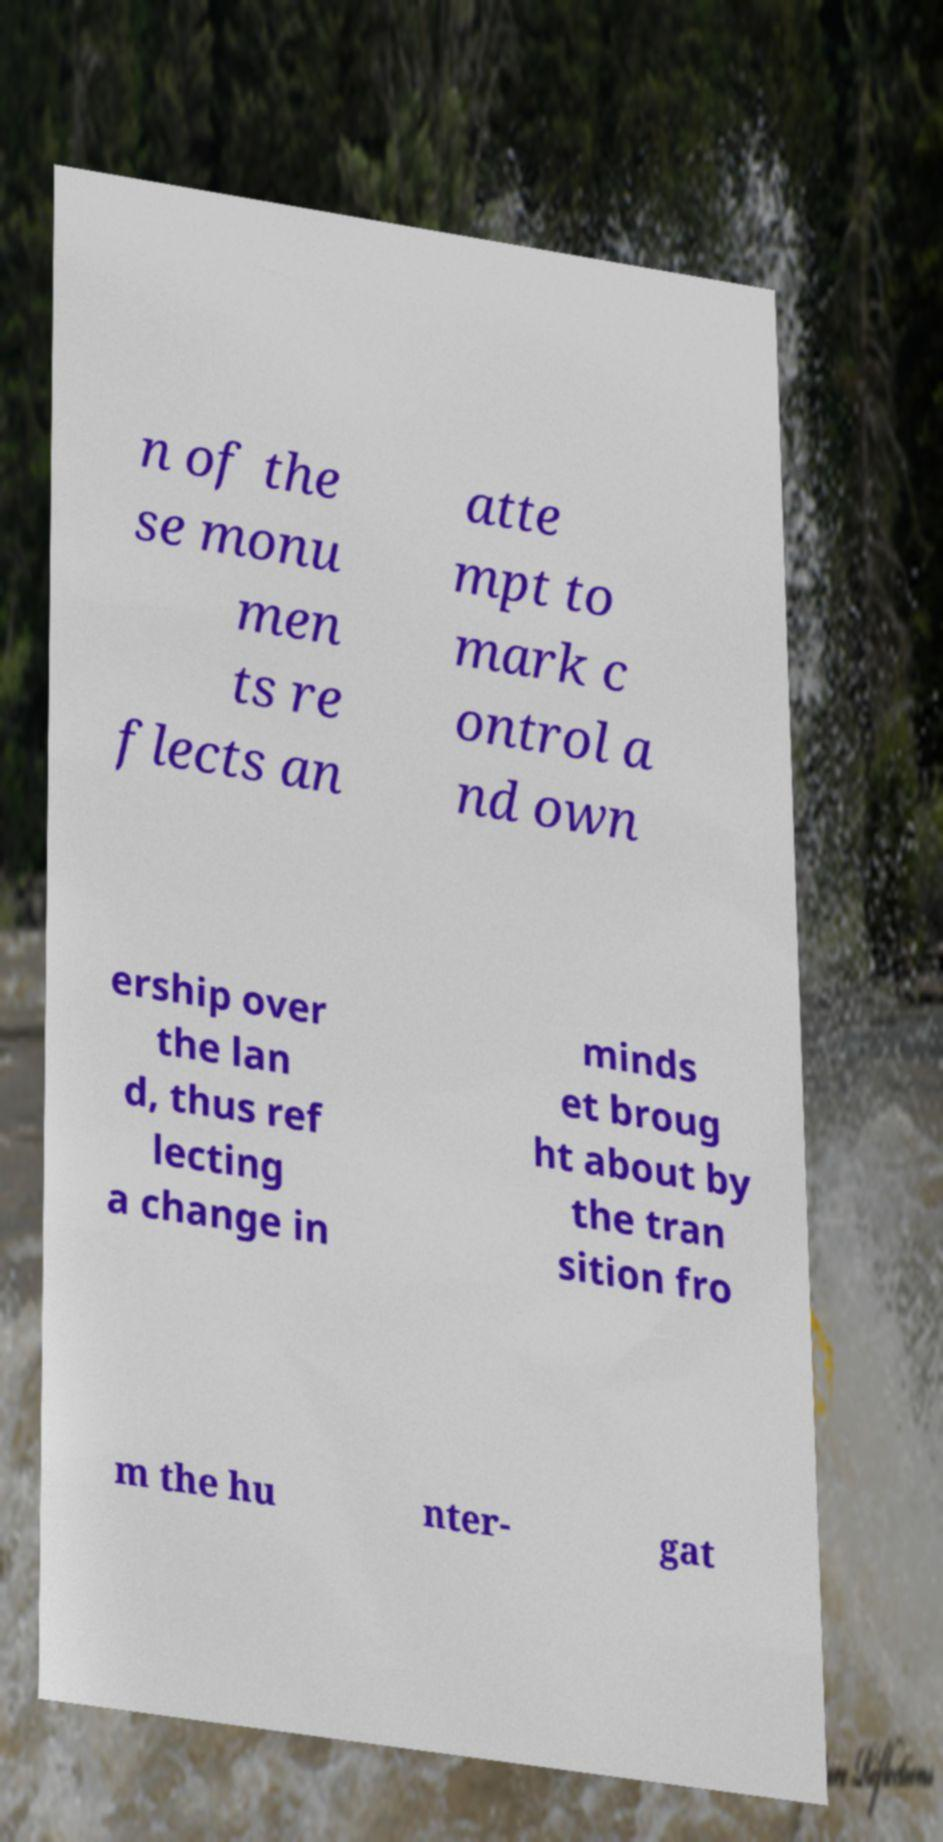Please read and relay the text visible in this image. What does it say? n of the se monu men ts re flects an atte mpt to mark c ontrol a nd own ership over the lan d, thus ref lecting a change in minds et broug ht about by the tran sition fro m the hu nter- gat 